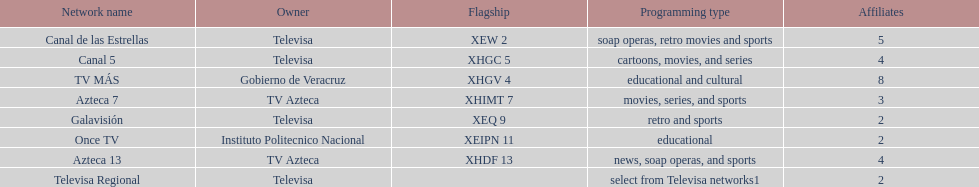Name each of tv azteca's network names. Azteca 7, Azteca 13. Could you help me parse every detail presented in this table? {'header': ['Network name', 'Owner', 'Flagship', 'Programming type', 'Affiliates'], 'rows': [['Canal de las Estrellas', 'Televisa', 'XEW 2', 'soap operas, retro movies and sports', '5'], ['Canal 5', 'Televisa', 'XHGC 5', 'cartoons, movies, and series', '4'], ['TV MÁS', 'Gobierno de Veracruz', 'XHGV 4', 'educational and cultural', '8'], ['Azteca 7', 'TV Azteca', 'XHIMT 7', 'movies, series, and sports', '3'], ['Galavisión', 'Televisa', 'XEQ 9', 'retro and sports', '2'], ['Once TV', 'Instituto Politecnico Nacional', 'XEIPN 11', 'educational', '2'], ['Azteca 13', 'TV Azteca', 'XHDF 13', 'news, soap operas, and sports', '4'], ['Televisa Regional', 'Televisa', '', 'select from Televisa networks1', '2']]} 